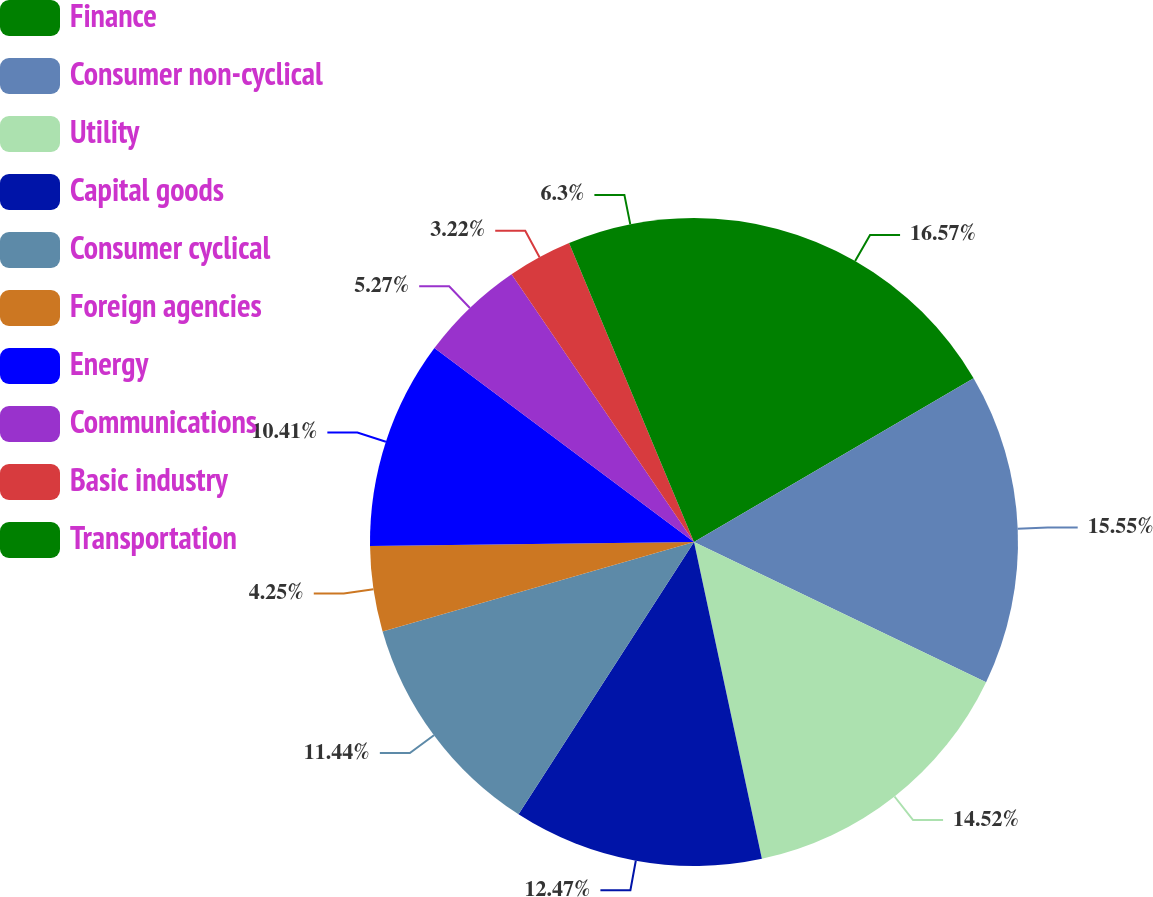Convert chart. <chart><loc_0><loc_0><loc_500><loc_500><pie_chart><fcel>Finance<fcel>Consumer non-cyclical<fcel>Utility<fcel>Capital goods<fcel>Consumer cyclical<fcel>Foreign agencies<fcel>Energy<fcel>Communications<fcel>Basic industry<fcel>Transportation<nl><fcel>16.57%<fcel>15.55%<fcel>14.52%<fcel>12.47%<fcel>11.44%<fcel>4.25%<fcel>10.41%<fcel>5.27%<fcel>3.22%<fcel>6.3%<nl></chart> 